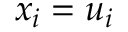Convert formula to latex. <formula><loc_0><loc_0><loc_500><loc_500>x _ { i } = u _ { i }</formula> 